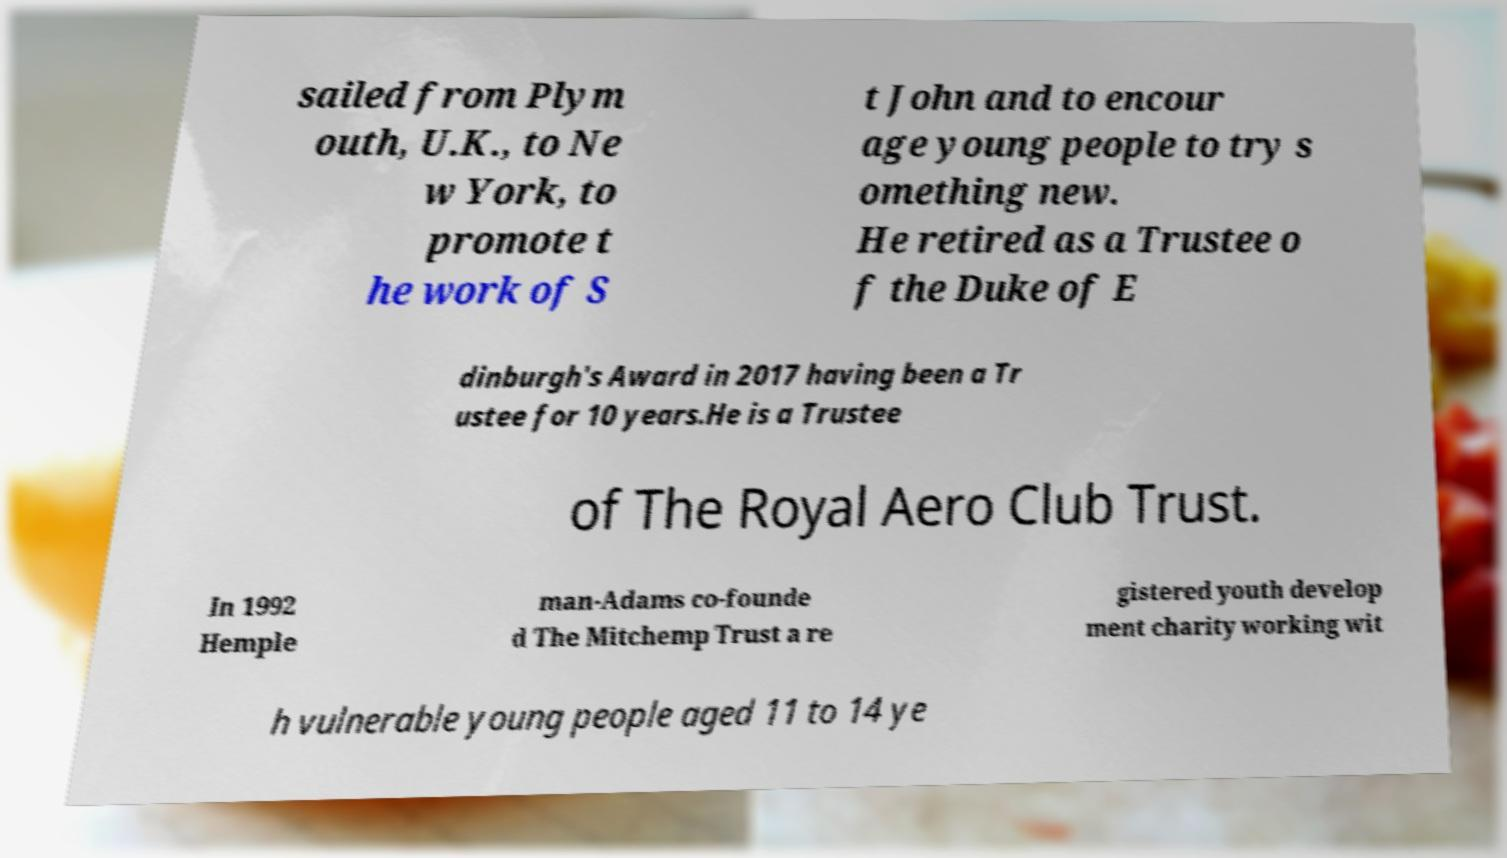For documentation purposes, I need the text within this image transcribed. Could you provide that? sailed from Plym outh, U.K., to Ne w York, to promote t he work of S t John and to encour age young people to try s omething new. He retired as a Trustee o f the Duke of E dinburgh's Award in 2017 having been a Tr ustee for 10 years.He is a Trustee of The Royal Aero Club Trust. In 1992 Hemple man-Adams co-founde d The Mitchemp Trust a re gistered youth develop ment charity working wit h vulnerable young people aged 11 to 14 ye 